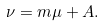Convert formula to latex. <formula><loc_0><loc_0><loc_500><loc_500>\nu = m \mu + A .</formula> 